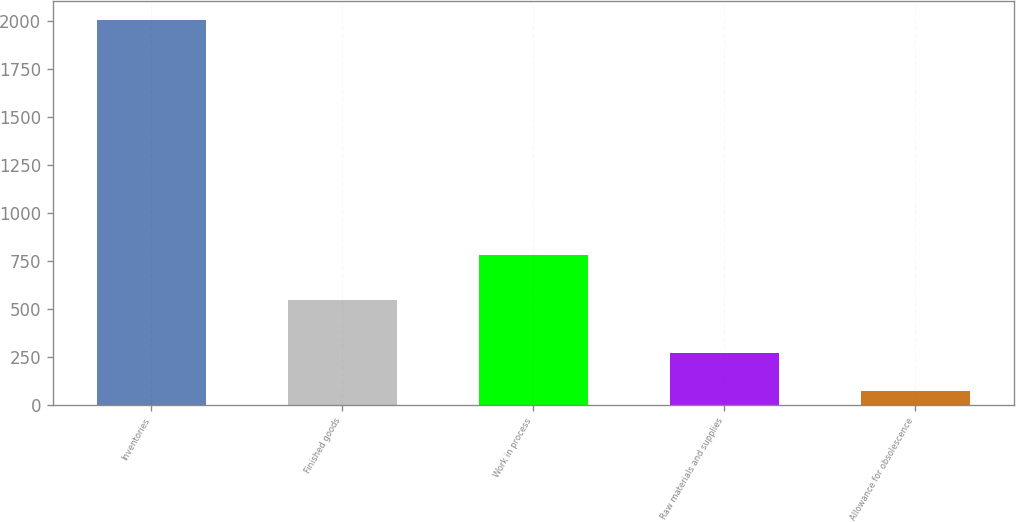<chart> <loc_0><loc_0><loc_500><loc_500><bar_chart><fcel>Inventories<fcel>Finished goods<fcel>Work in process<fcel>Raw materials and supplies<fcel>Allowance for obsolescence<nl><fcel>2007<fcel>547<fcel>784<fcel>271<fcel>70<nl></chart> 